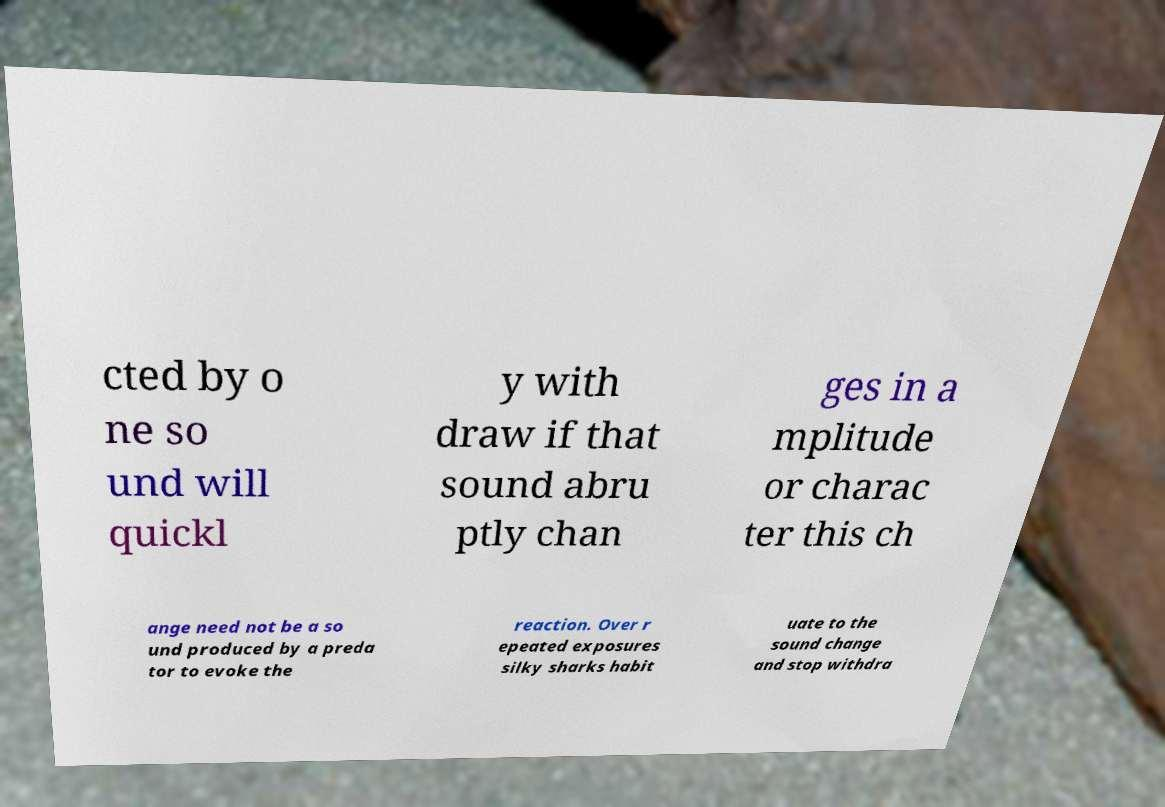Can you read and provide the text displayed in the image?This photo seems to have some interesting text. Can you extract and type it out for me? cted by o ne so und will quickl y with draw if that sound abru ptly chan ges in a mplitude or charac ter this ch ange need not be a so und produced by a preda tor to evoke the reaction. Over r epeated exposures silky sharks habit uate to the sound change and stop withdra 